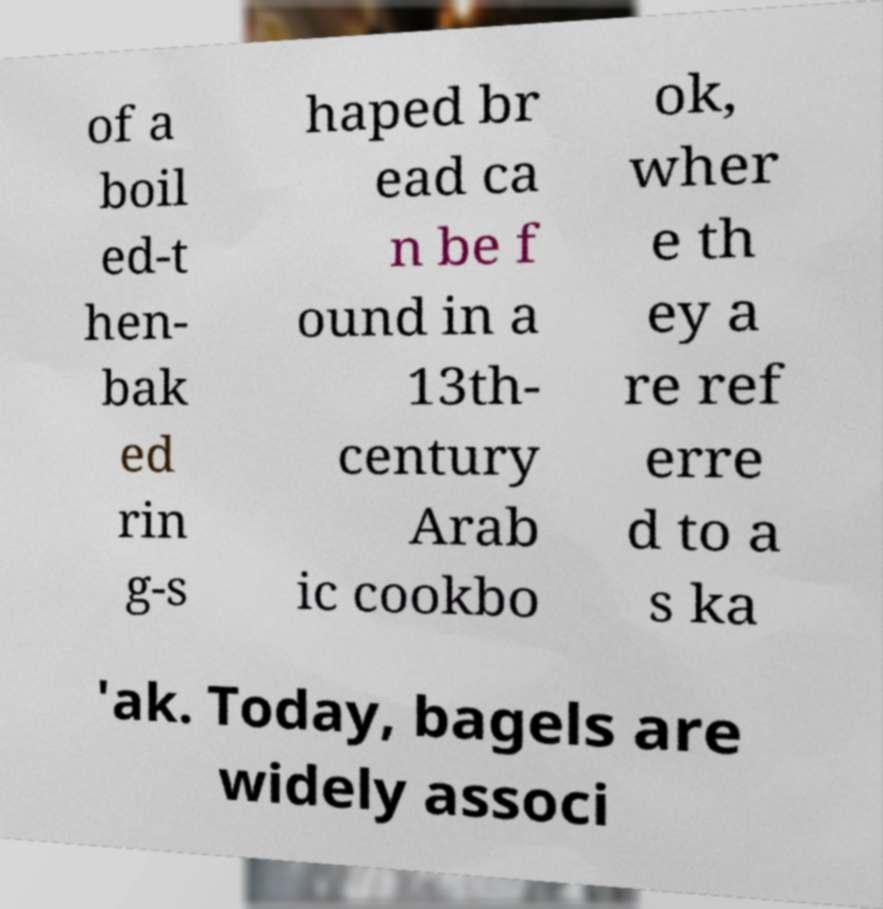Could you assist in decoding the text presented in this image and type it out clearly? of a boil ed-t hen- bak ed rin g-s haped br ead ca n be f ound in a 13th- century Arab ic cookbo ok, wher e th ey a re ref erre d to a s ka 'ak. Today, bagels are widely associ 